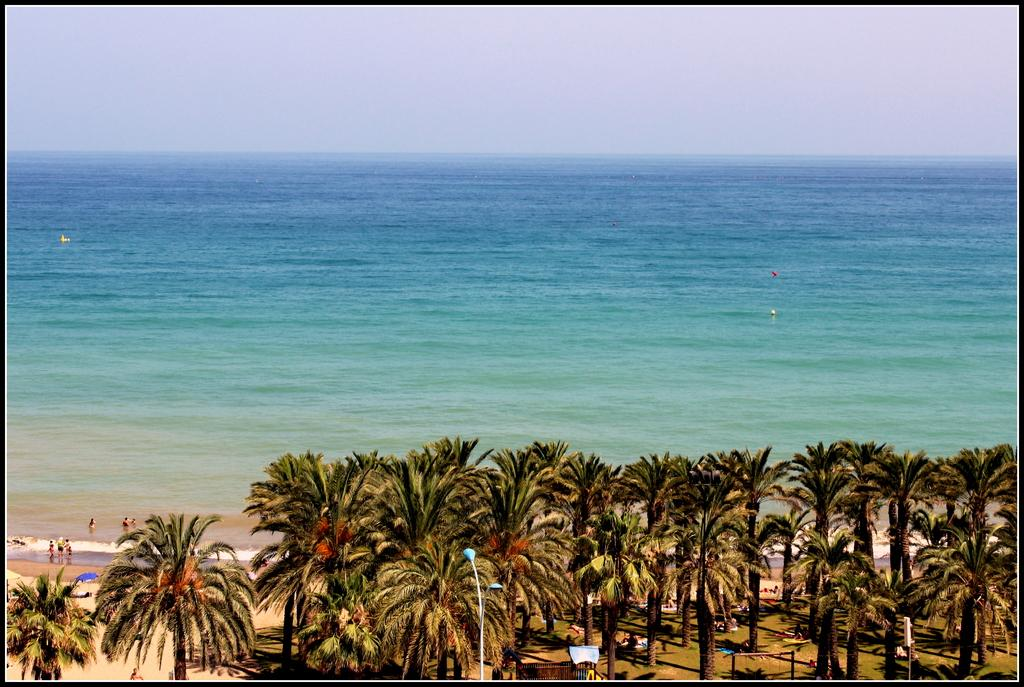What is the main structure in the image? There is a pole in the image. What type of natural elements can be seen in the image? There are trees and water visible in the image. What is located on the right side of the image? There is a board on the right side of the image. Can you describe the people visible in the image? There are people visible in the image, but their specific actions or characteristics are not mentioned in the provided facts. What type of paper is floating on the water in the image? There is no paper visible in the image; only trees, water, and a pole are mentioned. 